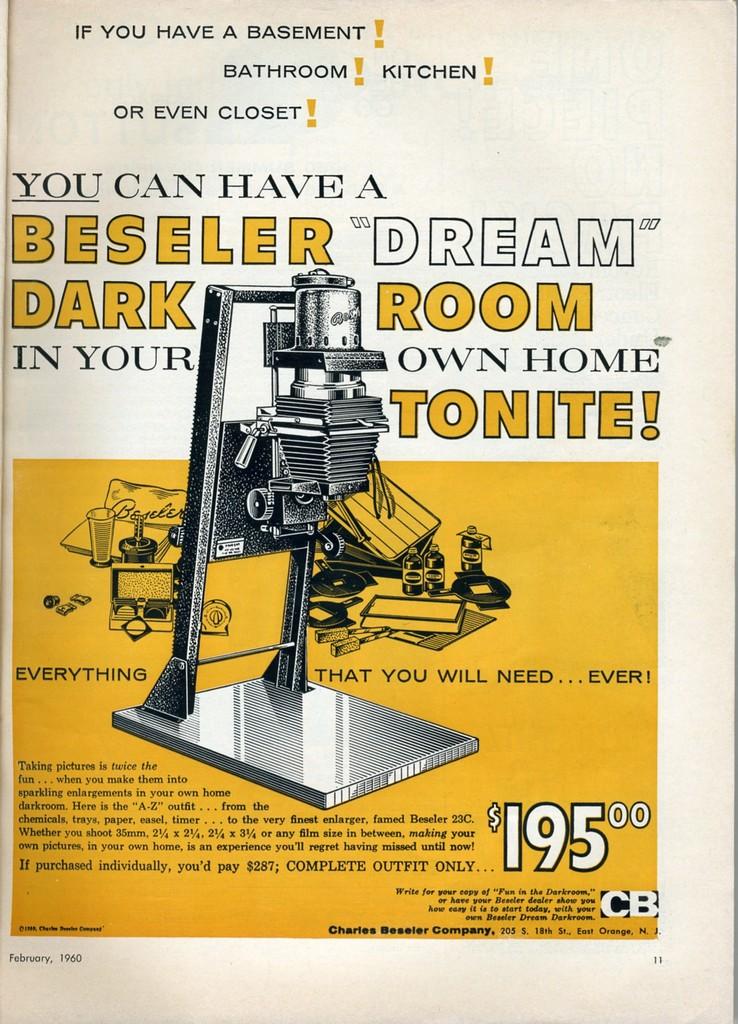What is the price listed for this?
Your response must be concise. $195. What can you have in your own home tonight?
Provide a succinct answer. Beseler dream dark room. 